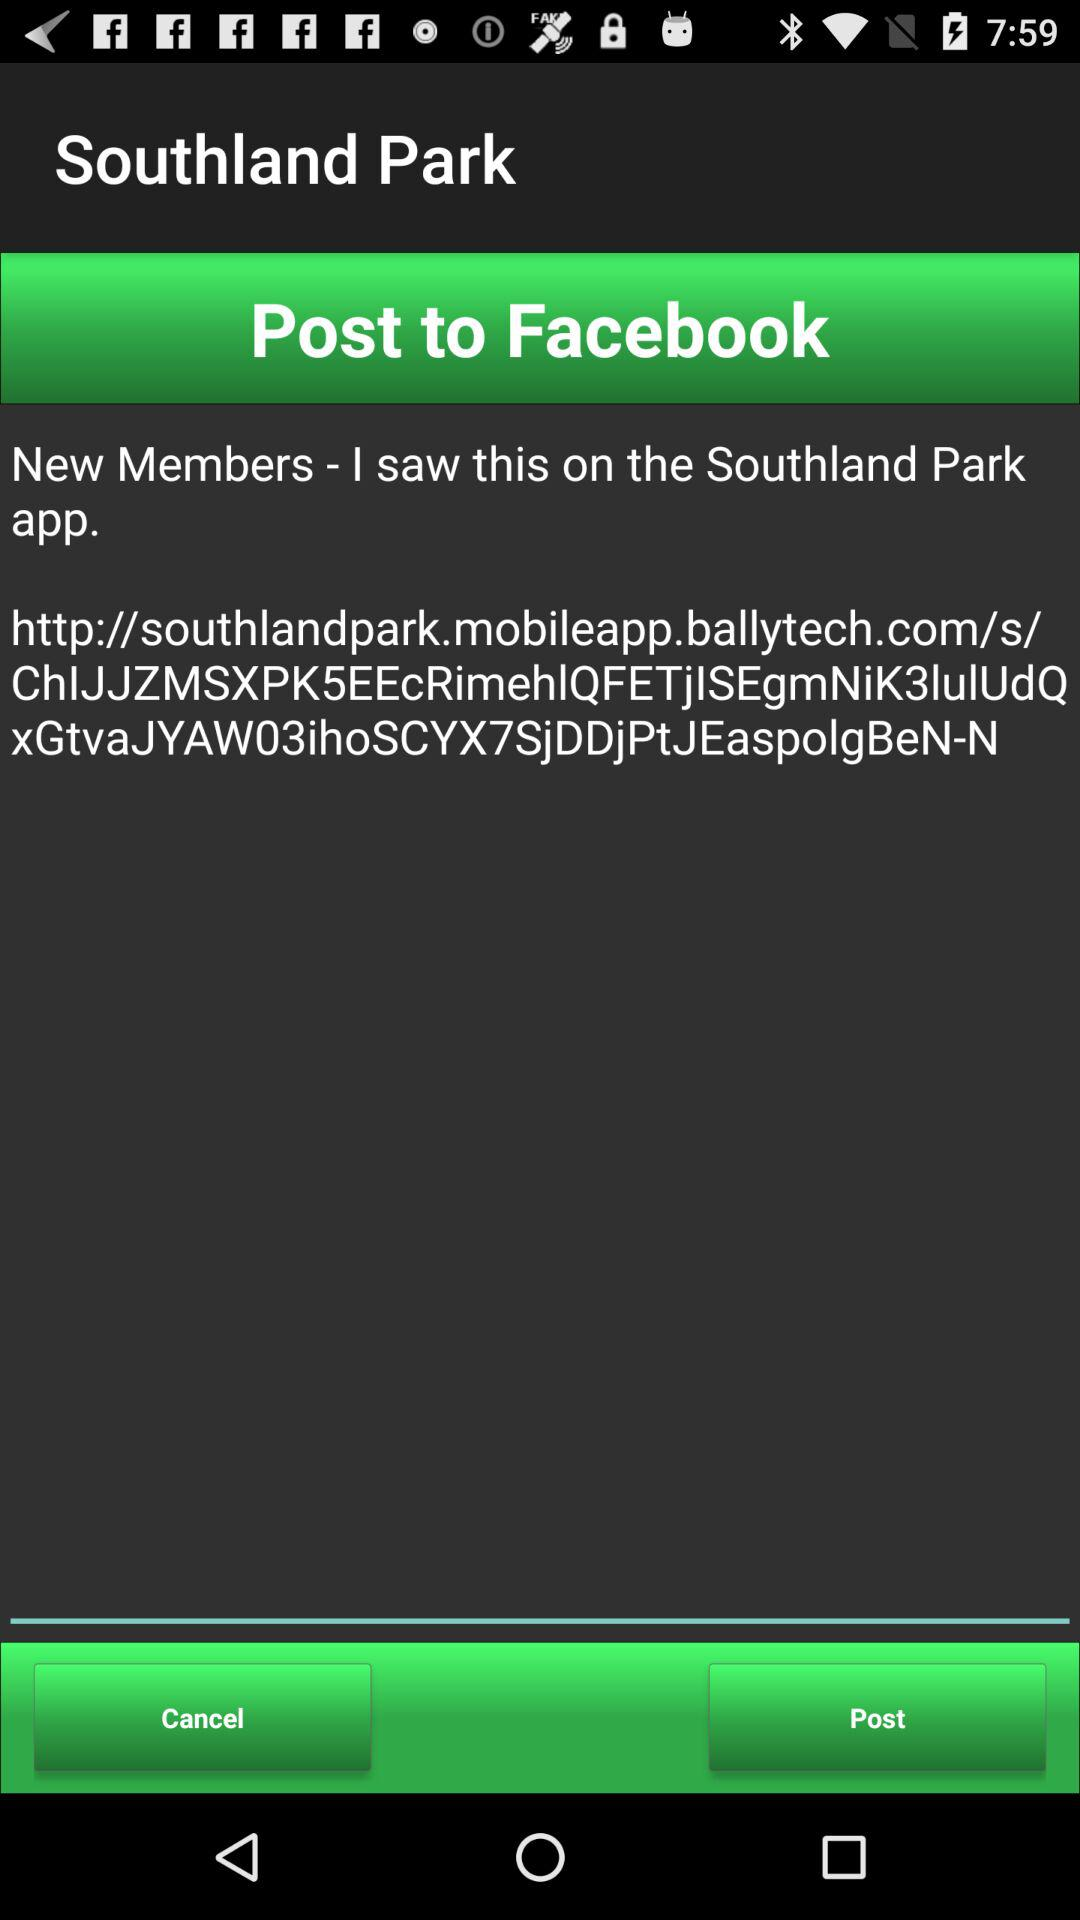What is the location?
When the provided information is insufficient, respond with <no answer>. <no answer> 